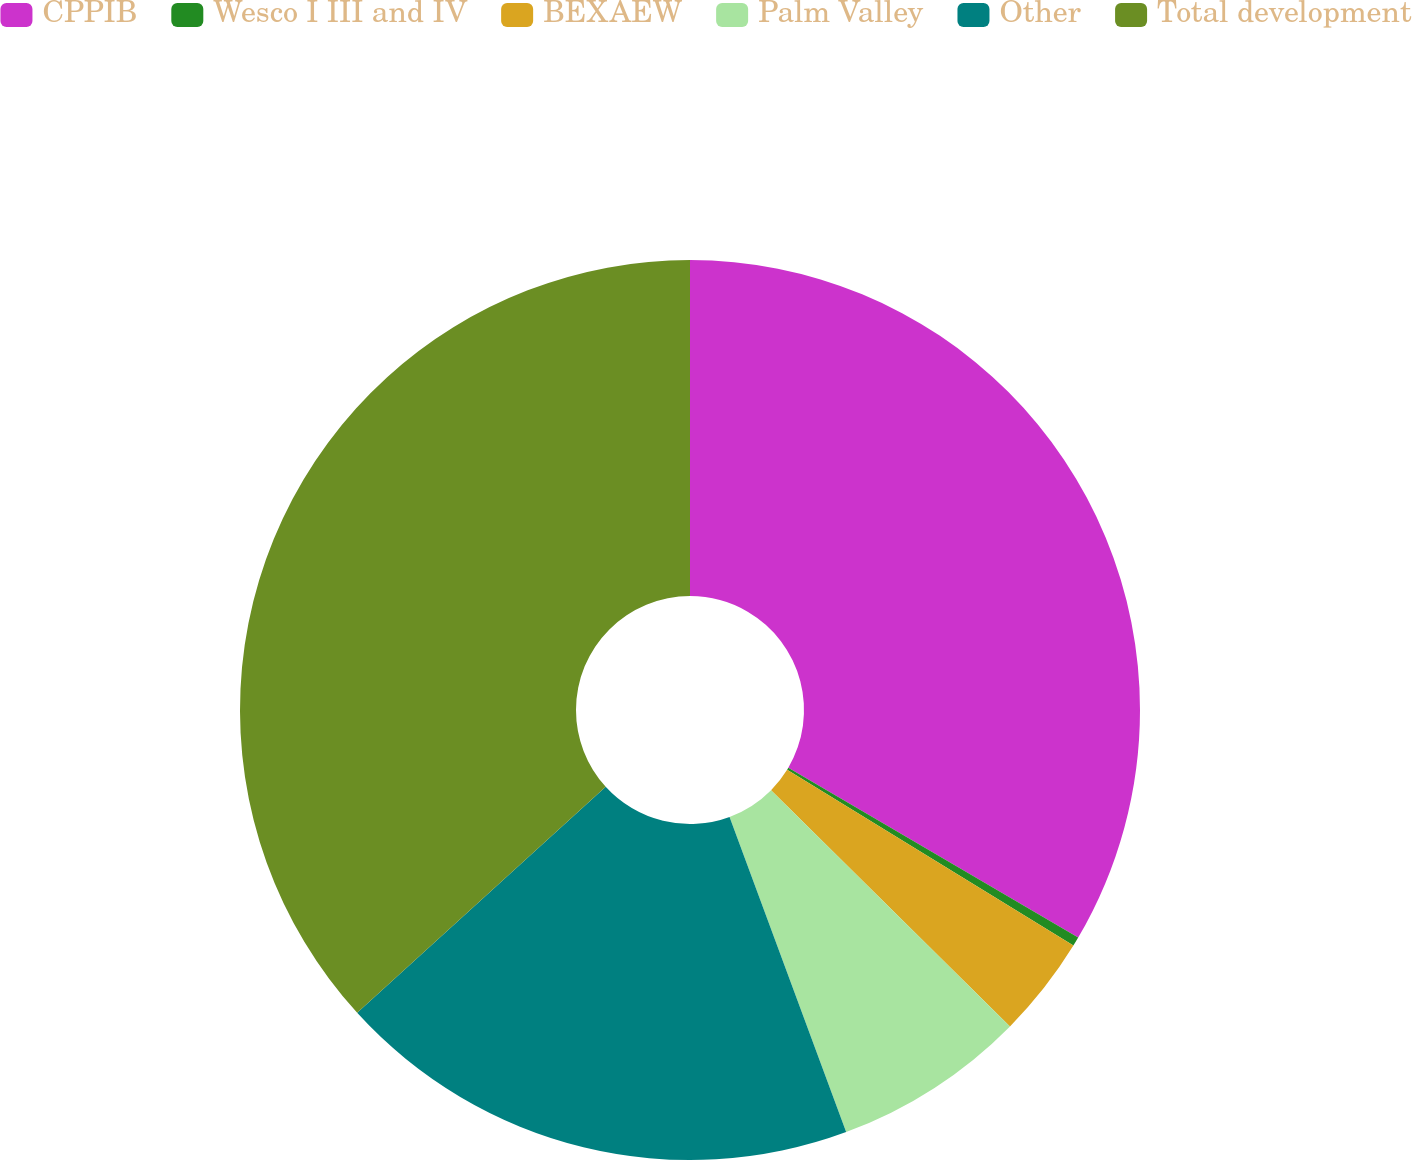Convert chart. <chart><loc_0><loc_0><loc_500><loc_500><pie_chart><fcel>CPPIB<fcel>Wesco I III and IV<fcel>BEXAEW<fcel>Palm Valley<fcel>Other<fcel>Total development<nl><fcel>33.44%<fcel>0.33%<fcel>3.64%<fcel>6.95%<fcel>18.89%<fcel>36.75%<nl></chart> 